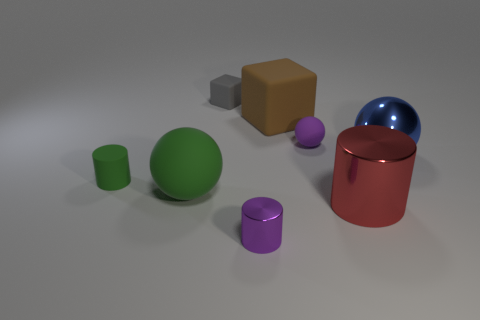The ball that is the same color as the tiny rubber cylinder is what size?
Offer a very short reply. Large. There is a big blue object that is the same shape as the tiny purple matte thing; what is it made of?
Keep it short and to the point. Metal. What number of small objects are in front of the sphere left of the small gray rubber thing?
Provide a short and direct response. 1. Is there anything else of the same color as the large matte sphere?
Offer a very short reply. Yes. How many things are tiny brown blocks or small objects to the left of the small purple cylinder?
Give a very brief answer. 2. What is the material of the small cylinder in front of the small thing to the left of the large ball left of the blue metal object?
Keep it short and to the point. Metal. What is the size of the purple cylinder that is made of the same material as the blue object?
Keep it short and to the point. Small. What color is the big rubber object behind the tiny purple object that is right of the purple cylinder?
Make the answer very short. Brown. How many cylinders are the same material as the gray thing?
Your response must be concise. 1. How many shiny objects are purple balls or large purple blocks?
Your answer should be very brief. 0. 